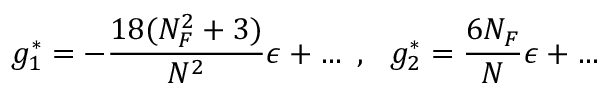Convert formula to latex. <formula><loc_0><loc_0><loc_500><loc_500>g _ { 1 } ^ { * } = - \frac { 1 8 ( N _ { F } ^ { 2 } + 3 ) } { N ^ { 2 } } \epsilon + , g _ { 2 } ^ { * } = \frac { 6 N _ { F } } { N } \epsilon + \dots</formula> 